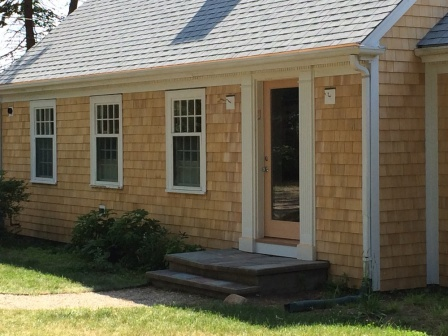What might be the history or background of this house? This charming house might have a rich history, perhaps dating back several decades. Its natural wood siding and classic architecture suggest that it could have been built in the mid-20th century. The meticulous maintenance hints that it has likely been passed down through generations, with each owner taking pride in preserving its original charm.

The inviting front door, slightly ajar with glass panels, might have witnessed countless family gatherings and celebrations over the years. The neatly arranged bushes and stone walkway indicate a long-standing tradition of tending to the garden with care. This house may have many stories to tell, from the laughter of children playing in the yard to the cozy evenings spent indoors. Imagine what it would be like to grow up in this house. Describe a typical day. Growing up in this picturesque house would likely have been a delightful experience. A typical day might start with the sun streaming through the three windows, filling the room with a warm glow. The day would begin with breakfast at the kitchen table, the delicious aroma of coffee and toast wafting through the air.

Children might rush out to play in the lush green lawn, laughing and chasing each other along the winding stone walkway. The blue hose indicates a love for outdoor activities, possibly watering the garden or filling a small pool on sunny days. Afternoons could be spent studying or reading by the light-filled windows, while evenings might involve family dinners, storytelling, or playing board games in the cozy interior.

Summers would bring barbecues and outdoor gatherings, with friends and family visiting, walking up the stone path to the welcoming front door. The house, with its inviting ambiance and beautifully maintained exterior, would be the perfect backdrop for the joyful memories of growing up. Create a fictional story set in this house, involving a hidden treasure. Years ago, in this quaint home with its striking natural wood siding and immaculate maintenance, an old legend whispered through the generations. It was said that the original owner, a ship captain from the early 1900s, had hidden a small treasure somewhere within the house before he sailed off on his last voyage.

The current owners, a curious family, decided to delve into the mystery one summer. Every evening, after dinner, they would gather in the living room, searching for clues left within the house's walls. Old letters found in the attic hinted at the existence of a hidden compartment beneath the stone walkway leading up to the door.

With great excitement, the family carefully lifted the stones, uncovering a small wooden box containing a golden compass and a map marked with curious symbols. The compass seemed to point to a large oak tree at the edge of the property. Digging beneath the tree, the family discovered a chest filled with relics from the ship captain's voyages—coins, ornate jewelry, and a leather-bound journal recounting his adventures.

The treasure brought the family closer together, teaching them the value of curiosity, teamwork, and the rich history hidden in the most unexpected places. 